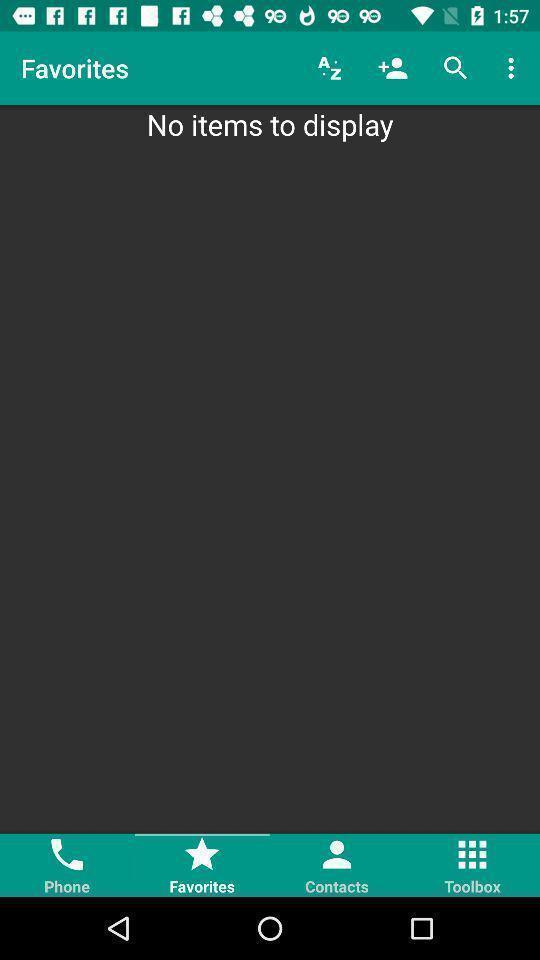Please provide a description for this image. Page to add favorites with options and search bar. 